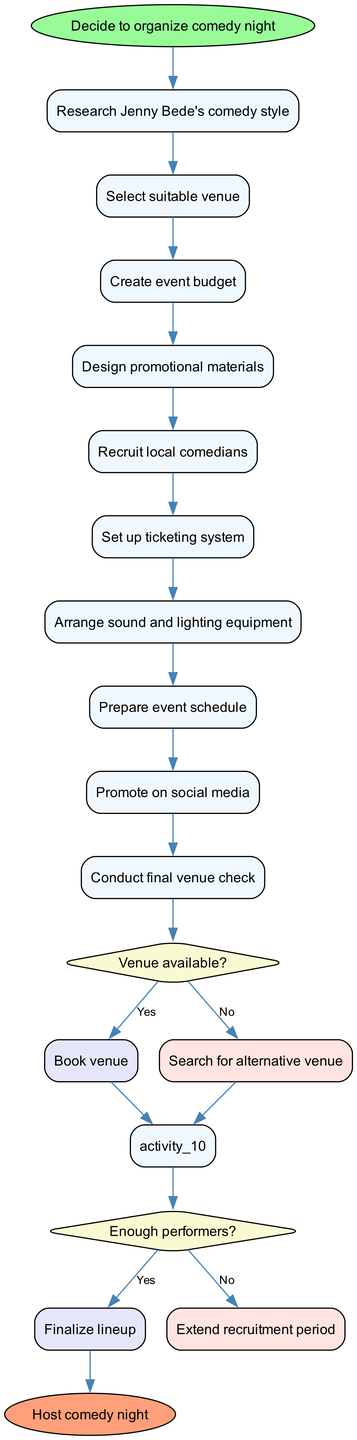What is the starting activity of this diagram? The starting activity is listed as "Decide to organize comedy night", which is the first node in the diagram.
Answer: Decide to organize comedy night How many activities are involved in this comedy night organization? There are a total of 9 activities listed in the diagram, which are connected in sequence after the starting node.
Answer: 9 What is the first decision point in this diagram? The first decision point is about "Venue available?", which follows the activities leading up to the venue selection.
Answer: Venue available? What happens if the venue is not available? If the venue is not available, the flow directs to "Search for alternative venue", which is the path taken if the answer to the decision is "No".
Answer: Search for alternative venue What do you do if you have enough performers? If there are enough performers, the flow leads to "Finalize lineup", which is the outcome of answering "Yes" to the decision about performers.
Answer: Finalize lineup How many decision points are in the diagram? There are 2 decision points present in the diagram, each representing a choice during the organization process.
Answer: 2 What is the final node in the diagram? The final node, which indicates the completion of the process, is "Host comedy night". This is where all paths lead ultimately.
Answer: Host comedy night What is the activity that follows designing promotional materials? After "Design promotional materials", the next activity is "Recruit local comedians" as indicated by the sequence of activities in the diagram.
Answer: Recruit local comedians What is the outcome if the recruitment period is extended? If the recruitment period is extended, it will loop back to recruitment activities, allowing for more time to find additional comedians.
Answer: Extend recruitment period 